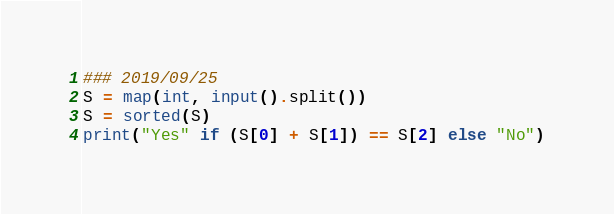<code> <loc_0><loc_0><loc_500><loc_500><_Python_>### 2019/09/25
S = map(int, input().split())
S = sorted(S)
print("Yes" if (S[0] + S[1]) == S[2] else "No")</code> 